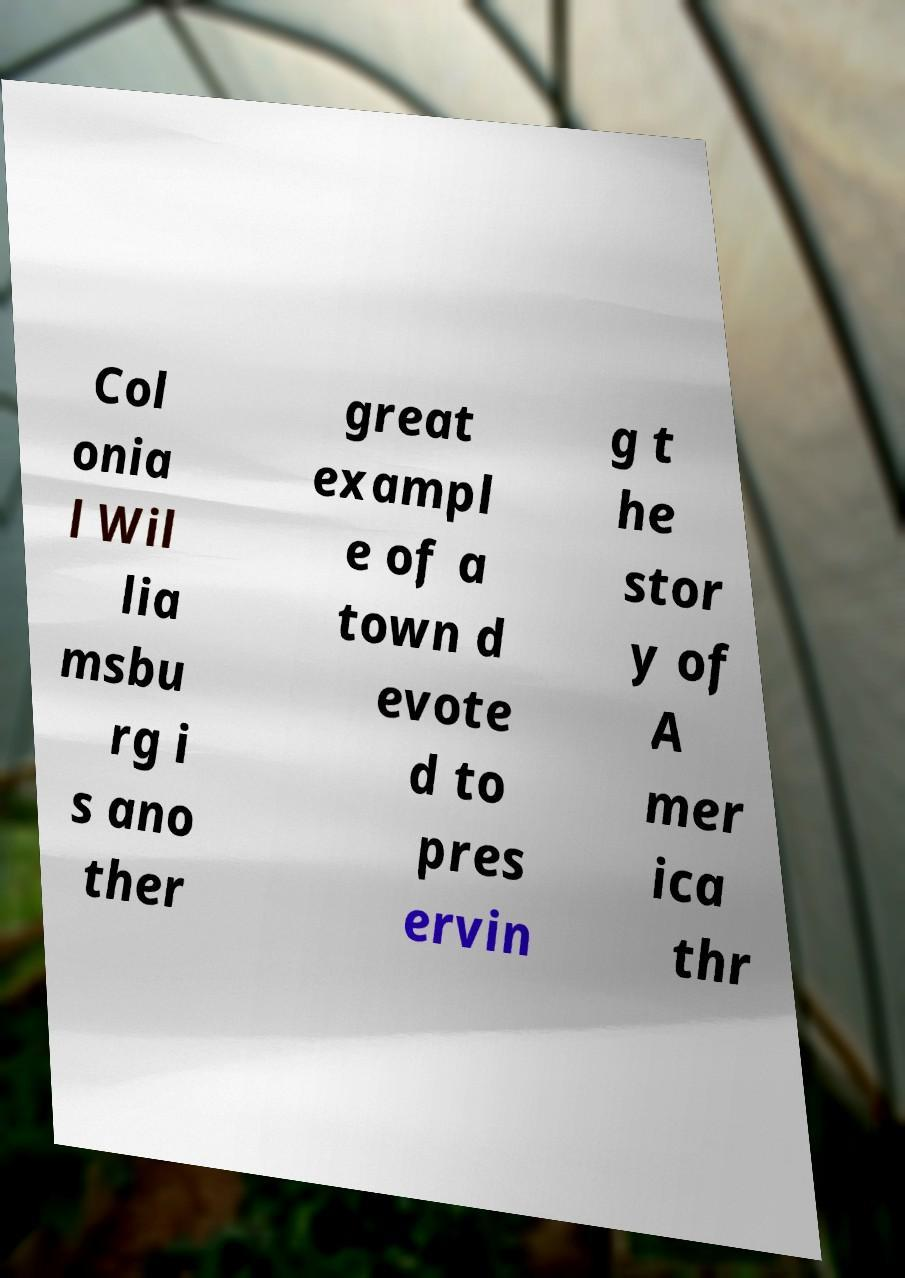There's text embedded in this image that I need extracted. Can you transcribe it verbatim? Col onia l Wil lia msbu rg i s ano ther great exampl e of a town d evote d to pres ervin g t he stor y of A mer ica thr 